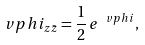<formula> <loc_0><loc_0><loc_500><loc_500>\ v p h i _ { z \bar { z } } = \frac { 1 } { 2 } \, e ^ { \ v p h i } ,</formula> 